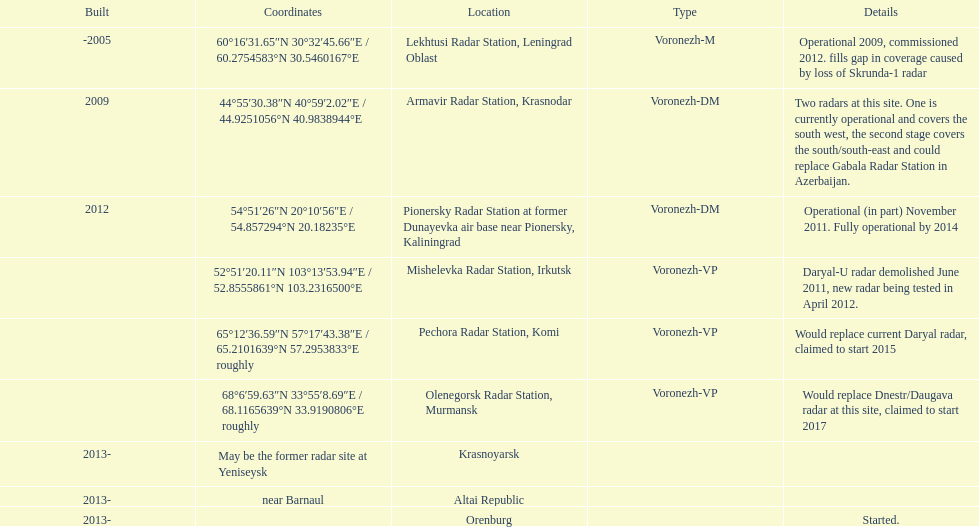What is the only location with a coordination of 60°16&#8242;31.65&#8243;n 30°32&#8242;45.66&#8243;e / 60.2754583°n 30.5460167°e? Lekhtusi Radar Station, Leningrad Oblast. I'm looking to parse the entire table for insights. Could you assist me with that? {'header': ['Built', 'Coordinates', 'Location', 'Type', 'Details'], 'rows': [['-2005', '60°16′31.65″N 30°32′45.66″E\ufeff / \ufeff60.2754583°N 30.5460167°E', 'Lekhtusi Radar Station, Leningrad Oblast', 'Voronezh-M', 'Operational 2009, commissioned 2012. fills gap in coverage caused by loss of Skrunda-1 radar'], ['2009', '44°55′30.38″N 40°59′2.02″E\ufeff / \ufeff44.9251056°N 40.9838944°E', 'Armavir Radar Station, Krasnodar', 'Voronezh-DM', 'Two radars at this site. One is currently operational and covers the south west, the second stage covers the south/south-east and could replace Gabala Radar Station in Azerbaijan.'], ['2012', '54°51′26″N 20°10′56″E\ufeff / \ufeff54.857294°N 20.18235°E', 'Pionersky Radar Station at former Dunayevka air base near Pionersky, Kaliningrad', 'Voronezh-DM', 'Operational (in part) November 2011. Fully operational by 2014'], ['', '52°51′20.11″N 103°13′53.94″E\ufeff / \ufeff52.8555861°N 103.2316500°E', 'Mishelevka Radar Station, Irkutsk', 'Voronezh-VP', 'Daryal-U radar demolished June 2011, new radar being tested in April 2012.'], ['', '65°12′36.59″N 57°17′43.38″E\ufeff / \ufeff65.2101639°N 57.2953833°E roughly', 'Pechora Radar Station, Komi', 'Voronezh-VP', 'Would replace current Daryal radar, claimed to start 2015'], ['', '68°6′59.63″N 33°55′8.69″E\ufeff / \ufeff68.1165639°N 33.9190806°E roughly', 'Olenegorsk Radar Station, Murmansk', 'Voronezh-VP', 'Would replace Dnestr/Daugava radar at this site, claimed to start 2017'], ['2013-', 'May be the former radar site at Yeniseysk', 'Krasnoyarsk', '', ''], ['2013-', 'near Barnaul', 'Altai Republic', '', ''], ['2013-', '', 'Orenburg', '', 'Started.']]} 